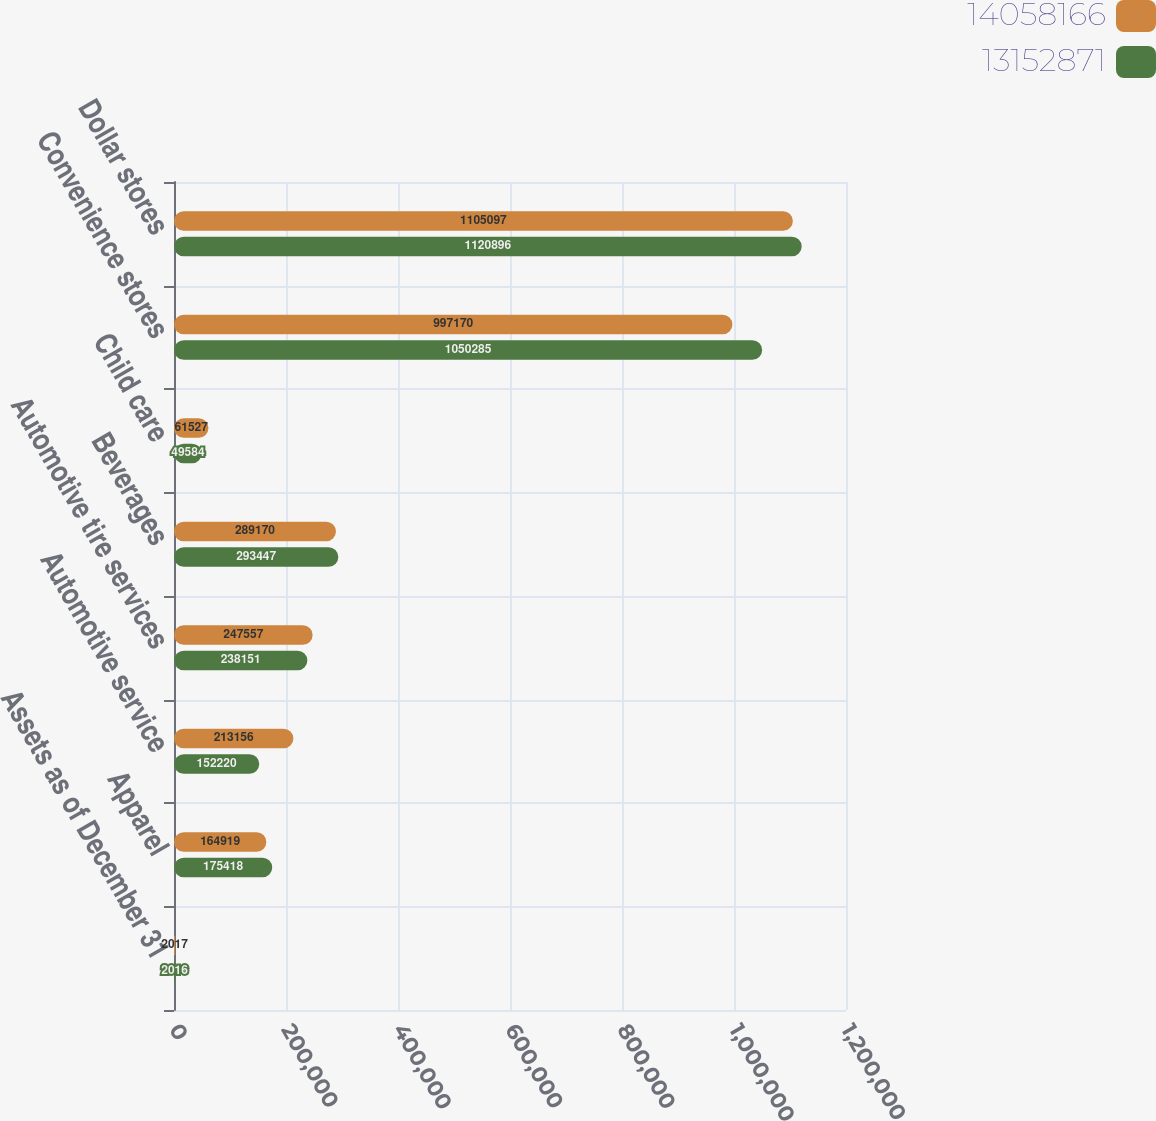Convert chart to OTSL. <chart><loc_0><loc_0><loc_500><loc_500><stacked_bar_chart><ecel><fcel>Assets as of December 31<fcel>Apparel<fcel>Automotive service<fcel>Automotive tire services<fcel>Beverages<fcel>Child care<fcel>Convenience stores<fcel>Dollar stores<nl><fcel>1.40582e+07<fcel>2017<fcel>164919<fcel>213156<fcel>247557<fcel>289170<fcel>61527<fcel>997170<fcel>1.1051e+06<nl><fcel>1.31529e+07<fcel>2016<fcel>175418<fcel>152220<fcel>238151<fcel>293447<fcel>49584<fcel>1.05028e+06<fcel>1.1209e+06<nl></chart> 